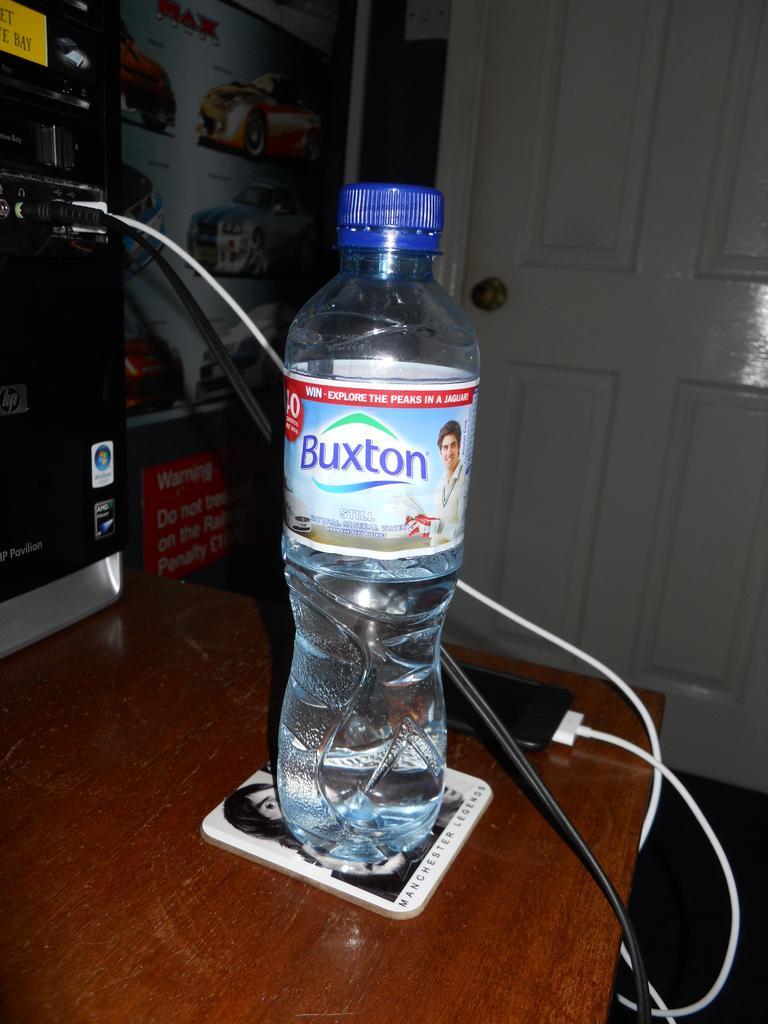What brand of car can you win from this bottle?
Your response must be concise. Jaguar. 